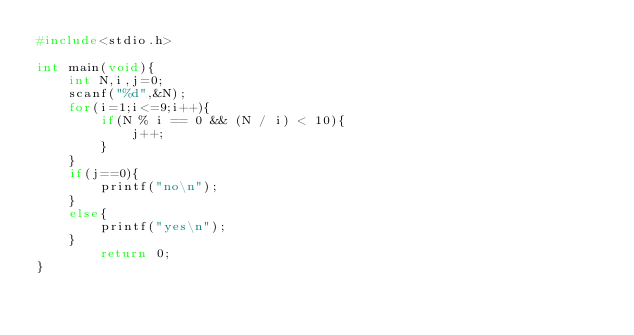<code> <loc_0><loc_0><loc_500><loc_500><_C_>#include<stdio.h>

int main(void){
    int N,i,j=0;
    scanf("%d",&N);
    for(i=1;i<=9;i++){
        if(N % i == 0 && (N / i) < 10){
            j++;
        }
    }
    if(j==0){
        printf("no\n");
    }
    else{
        printf("yes\n");
    }
        return 0;
}
   </code> 